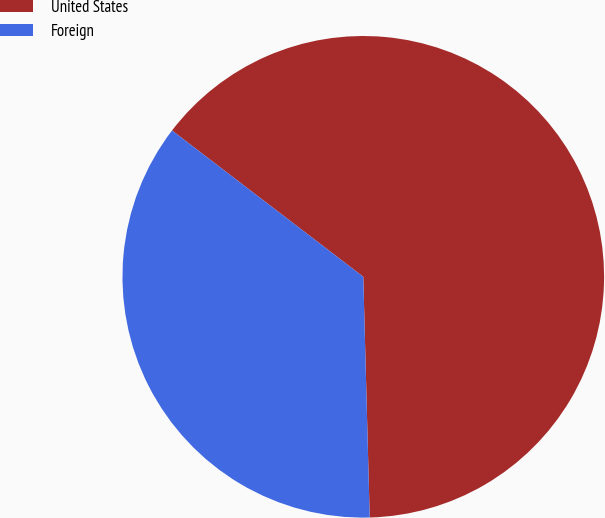Convert chart to OTSL. <chart><loc_0><loc_0><loc_500><loc_500><pie_chart><fcel>United States<fcel>Foreign<nl><fcel>64.18%<fcel>35.82%<nl></chart> 